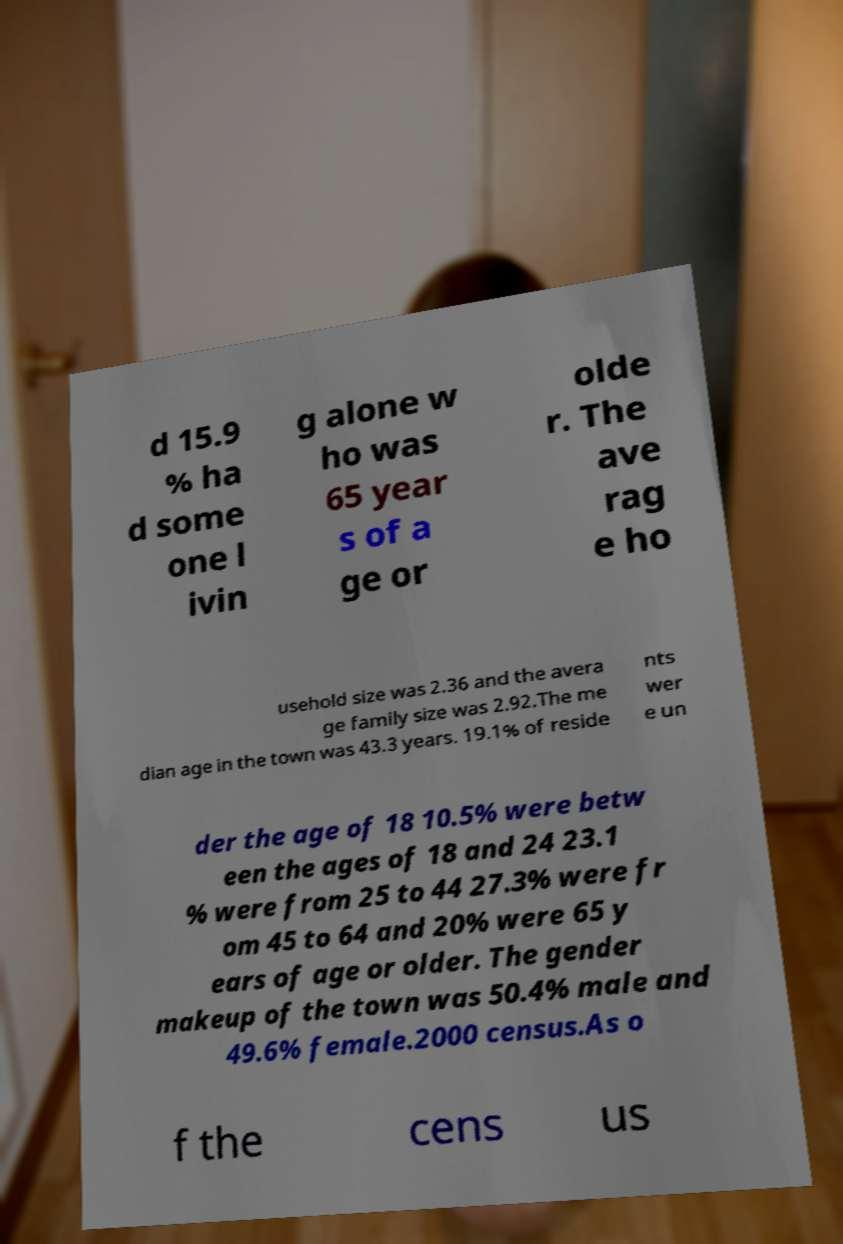I need the written content from this picture converted into text. Can you do that? d 15.9 % ha d some one l ivin g alone w ho was 65 year s of a ge or olde r. The ave rag e ho usehold size was 2.36 and the avera ge family size was 2.92.The me dian age in the town was 43.3 years. 19.1% of reside nts wer e un der the age of 18 10.5% were betw een the ages of 18 and 24 23.1 % were from 25 to 44 27.3% were fr om 45 to 64 and 20% were 65 y ears of age or older. The gender makeup of the town was 50.4% male and 49.6% female.2000 census.As o f the cens us 